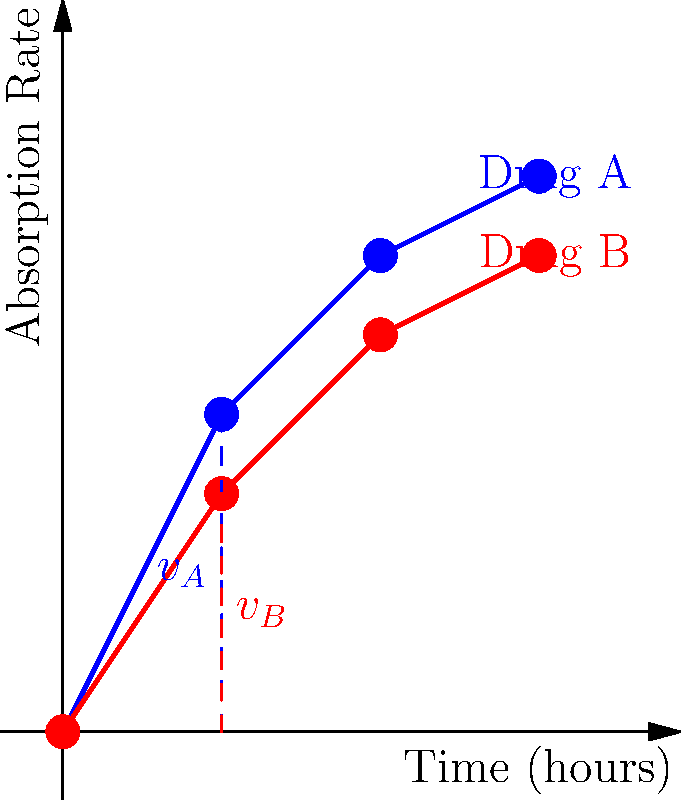Based on the graph showing the absorption rates of Drug A and Drug B over time, compare their initial absorption velocities at t = 1 hour using vector notation. Which drug has a higher initial absorption rate, and by what factor? To compare the initial absorption velocities of Drug A and Drug B at t = 1 hour:

1. Identify the absorption rates at t = 1 hour:
   Drug A: 2 units
   Drug B: 1.5 units

2. Express these as vectors:
   $\vec{v_A} = \begin{pmatrix} 1 \\ 2 \end{pmatrix}$
   $\vec{v_B} = \begin{pmatrix} 1 \\ 1.5 \end{pmatrix}$

3. Calculate the magnitude of each vector:
   $|\vec{v_A}| = \sqrt{1^2 + 2^2} = \sqrt{5} \approx 2.24$
   $|\vec{v_B}| = \sqrt{1^2 + 1.5^2} = \sqrt{3.25} \approx 1.80$

4. Compare the magnitudes:
   $\frac{|\vec{v_A}|}{|\vec{v_B}|} = \frac{2.24}{1.80} \approx 1.24$

5. Convert to a percentage:
   $(1.24 - 1) \times 100\% = 24\%$

Therefore, Drug A has a higher initial absorption rate, approximately 24% higher than Drug B.
Answer: Drug A; 24% higher 